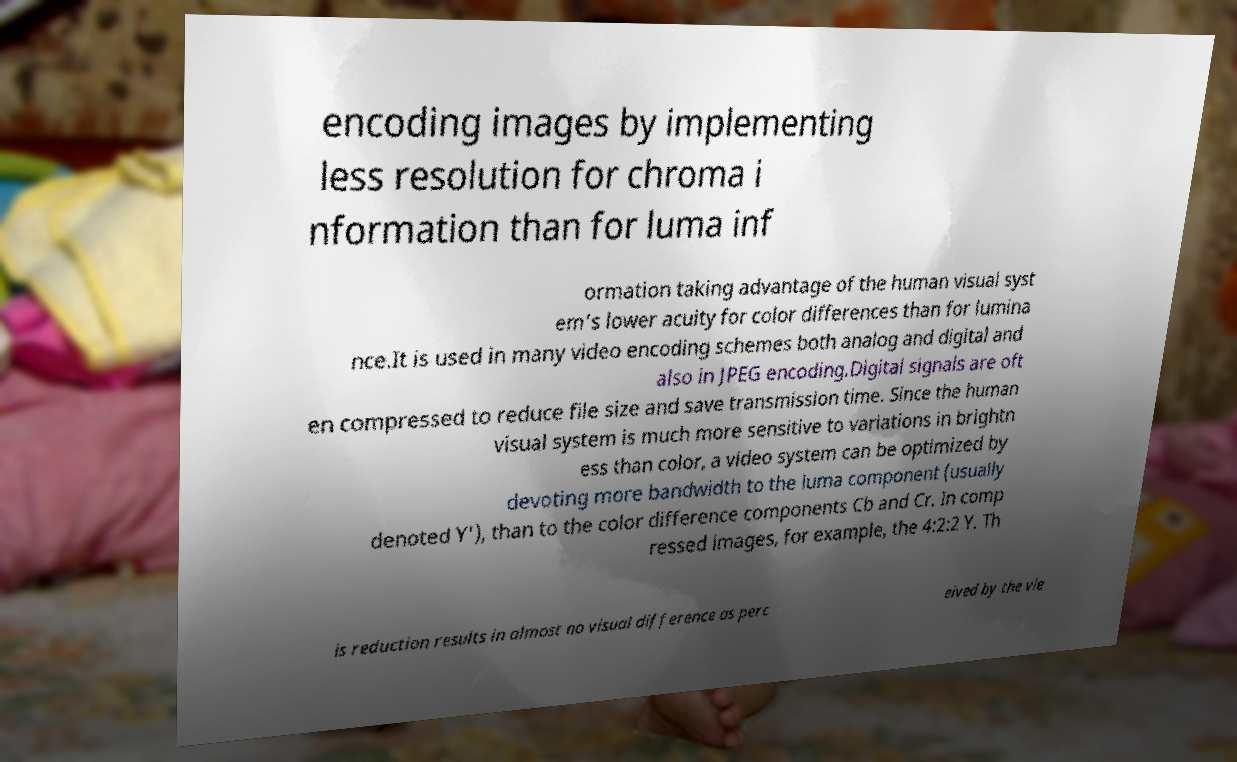There's text embedded in this image that I need extracted. Can you transcribe it verbatim? encoding images by implementing less resolution for chroma i nformation than for luma inf ormation taking advantage of the human visual syst em's lower acuity for color differences than for lumina nce.It is used in many video encoding schemes both analog and digital and also in JPEG encoding.Digital signals are oft en compressed to reduce file size and save transmission time. Since the human visual system is much more sensitive to variations in brightn ess than color, a video system can be optimized by devoting more bandwidth to the luma component (usually denoted Y'), than to the color difference components Cb and Cr. In comp ressed images, for example, the 4:2:2 Y. Th is reduction results in almost no visual difference as perc eived by the vie 